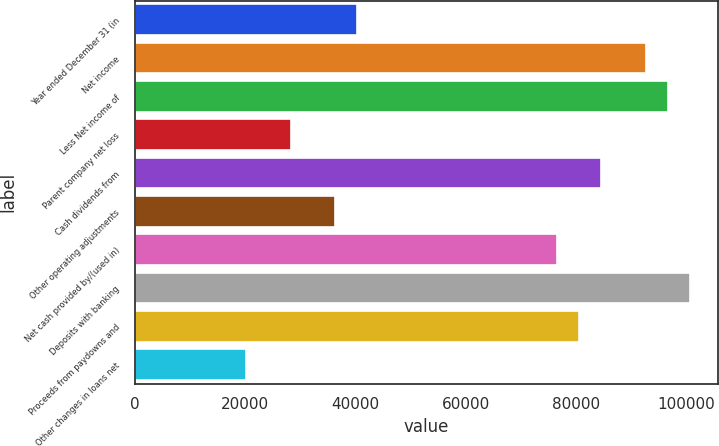Convert chart. <chart><loc_0><loc_0><loc_500><loc_500><bar_chart><fcel>Year ended December 31 (in<fcel>Net income<fcel>Less Net income of<fcel>Parent company net loss<fcel>Cash dividends from<fcel>Other operating adjustments<fcel>Net cash provided by/(used in)<fcel>Deposits with banking<fcel>Proceeds from paydowns and<fcel>Other changes in loans net<nl><fcel>40284<fcel>92611.6<fcel>96636.8<fcel>28208.4<fcel>84561.2<fcel>36258.8<fcel>76510.8<fcel>100662<fcel>80536<fcel>20158<nl></chart> 